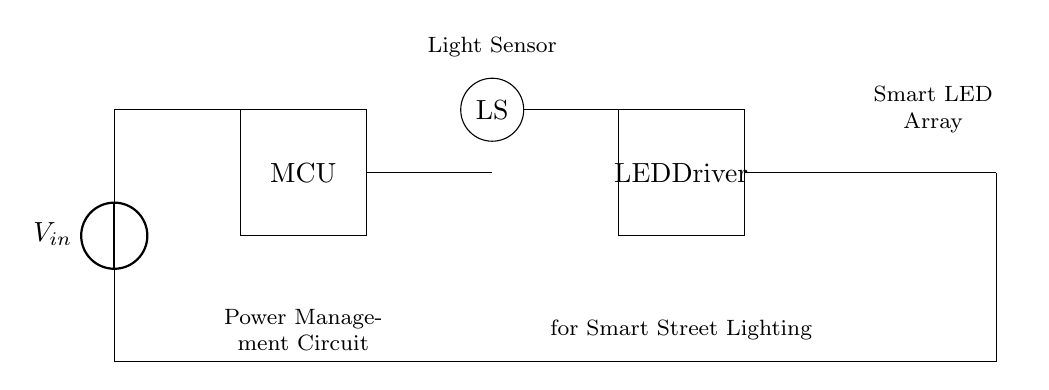What is the power source in this circuit? The power source is represented as a voltage source labeled V_in, which provides electrical energy to the circuit.
Answer: Voltage source What component detects ambient light? The light sensor, marked as LS in the circuit diagram, is responsible for detecting light levels to control the LED lighting.
Answer: Light sensor How many LEDs are in the LED array? The circuit shows three LED symbols in series, indicating that there are three LEDs included in the LED array for street lighting.
Answer: Three LEDs What is the role of the microcontroller? The microcontroller (MCU) manages the sensor inputs and controls the LED driver based on the data received from the light sensor.
Answer: Control How does the circuit reduce light pollution? The microcontroller uses data from the light sensor to adjust the brightness of the LEDs according to surrounding light levels, minimizing excess light emissions.
Answer: Adjusts brightness What is the purpose of the LED driver? The LED driver powers and regulates the current to the LED array, ensuring they operate efficiently while maintaining desired brightness levels.
Answer: Regulate current 